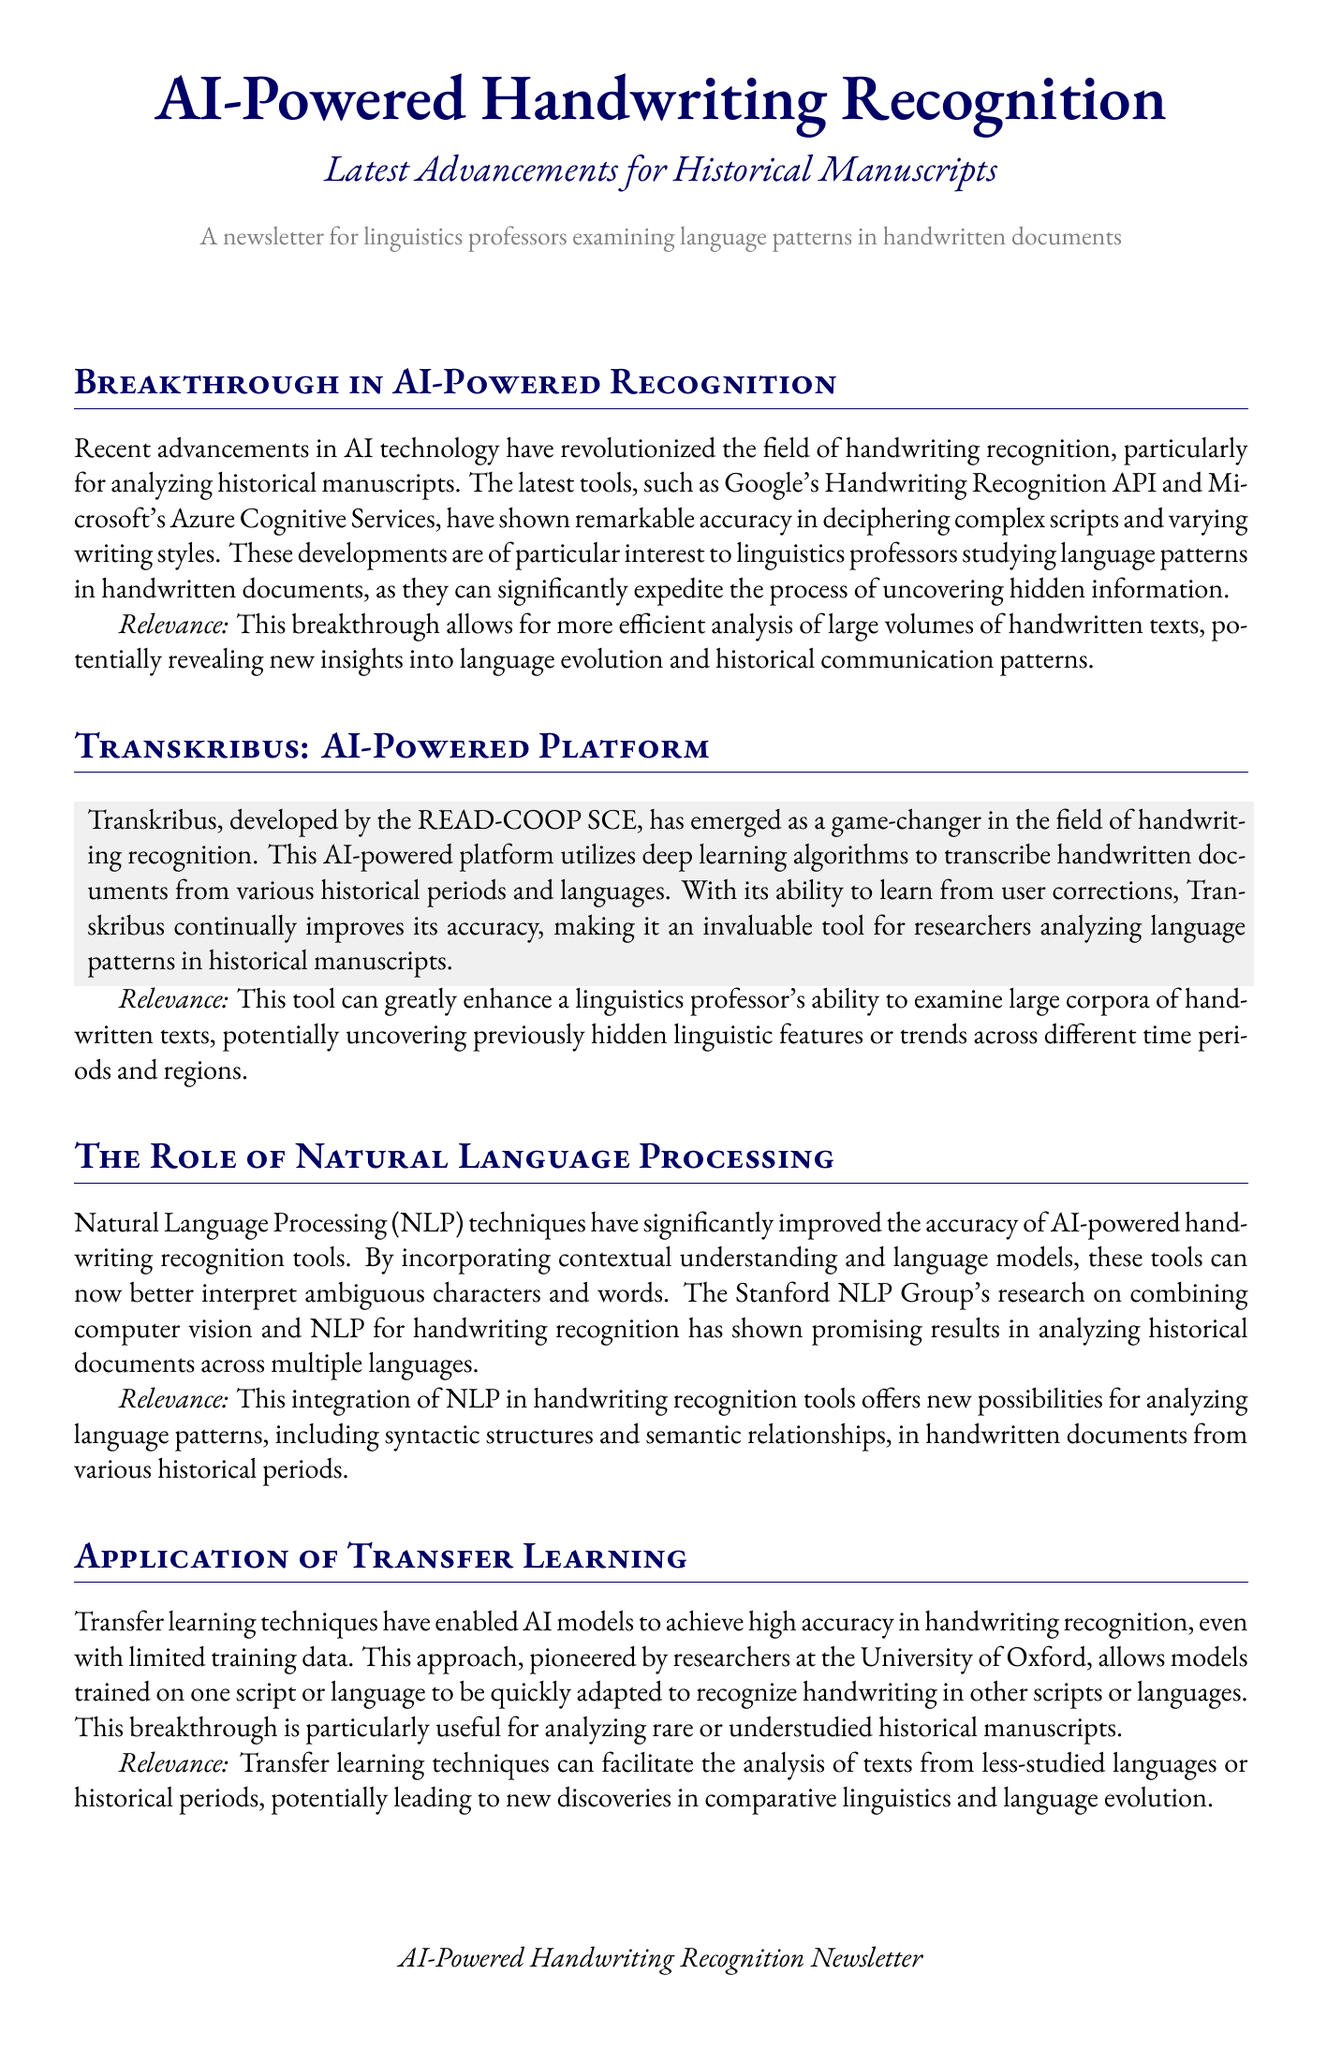What is the title of the newsletter? The title of the newsletter is prominently displayed at the top of the document.
Answer: AI-Powered Handwriting Recognition Who developed Transkribus? The document mentions the organization responsible for creating Transkribus.
Answer: READ-COOP SCE What methodological approach has improved handwriting recognition according to the newsletter? The newsletter discusses a specific approach that has enhanced recognition accuracy.
Answer: Natural Language Processing What is a significant advantage of transfer learning in handwriting recognition? The document describes a key benefit of transfer learning techniques.
Answer: High accuracy with limited data Which conference published guidelines on ethical AI use? The text specifically mentions the conference that released ethical guidelines for handwriting analysis.
Answer: ICDAR What type of algorithms does Transkribus utilize? The document states the type of algorithms employed by Transkribus for handwriting recognition.
Answer: Deep learning algorithms What is a potential outcome of utilizing AI-powered handwriting recognition tools? The newsletter outlines a specific benefit that these tools provide to researchers.
Answer: Expedite the process of uncovering hidden information What is emphasized regarding ethical concerns in handwriting analysis? The document highlights a key consideration concerning the use of AI tools.
Answer: Data protection 